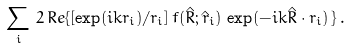Convert formula to latex. <formula><loc_0><loc_0><loc_500><loc_500>\sum _ { i } \, 2 \, R e \{ [ \exp ( i k r _ { i } ) / r _ { i } ] \, f ( \hat { R } ; \hat { r } _ { i } ) \, \exp ( - i k \hat { R } \cdot { r } _ { i } ) \, \} \, .</formula> 